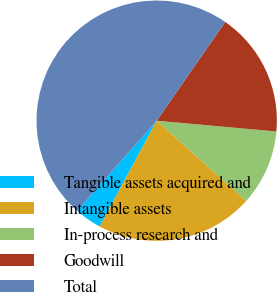Convert chart. <chart><loc_0><loc_0><loc_500><loc_500><pie_chart><fcel>Tangible assets acquired and<fcel>Intangible assets<fcel>In-process research and<fcel>Goodwill<fcel>Total<nl><fcel>3.65%<fcel>21.23%<fcel>10.21%<fcel>16.78%<fcel>48.14%<nl></chart> 